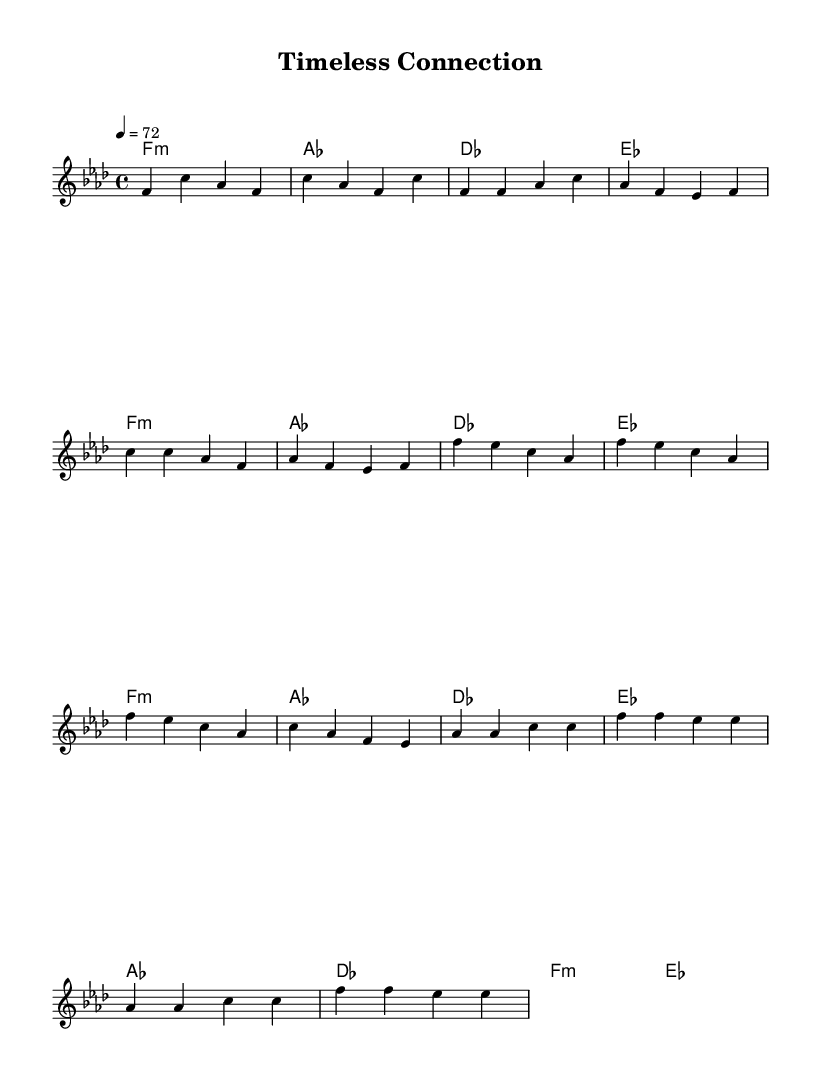What is the key signature of this music? The key signature is F minor, which has four flats (B♭, E♭, A♭, D♭). This can be determined by checking the key indicated at the beginning of the staff.
Answer: F minor What is the time signature of this music? The time signature is 4/4, which indicates four beats in each measure and a quarter note gets one beat. This can be determined by looking at the symbol indicating the time measure located at the beginning of the sheet music.
Answer: 4/4 What is the tempo marking in this music? The tempo marking is 72, which suggests that the quarter note is played at 72 beats per minute. The tempo is indicated at the beginning of the piece with the number following the word "tempo."
Answer: 72 How many measures are there in the chorus section? There are four measures in the chorus section. By counting the number of vertical lines (bar lines) in the chorus indicated by the notes, we find that there are four distinct segments.
Answer: 4 What is the harmonic structure in the bridge section? The harmonic structure in the bridge consists of four chords: A♭, D♭, F minor, and E♭. These chords are indicated in the chord mode section and help define the progression in the bridge area.
Answer: A♭, D♭, F minor, E♭ Which two artists are noted for their collaborations within the smooth R&B genre? Two classic artists known for their collaborations in smooth R&B are Marvin Gaye and Erykah Badu. This can be deduced from historical context, as these artists frequently blend classic sounds with modern production to create smooth R&B collaborations.
Answer: Marvin Gaye, Erykah Badu 